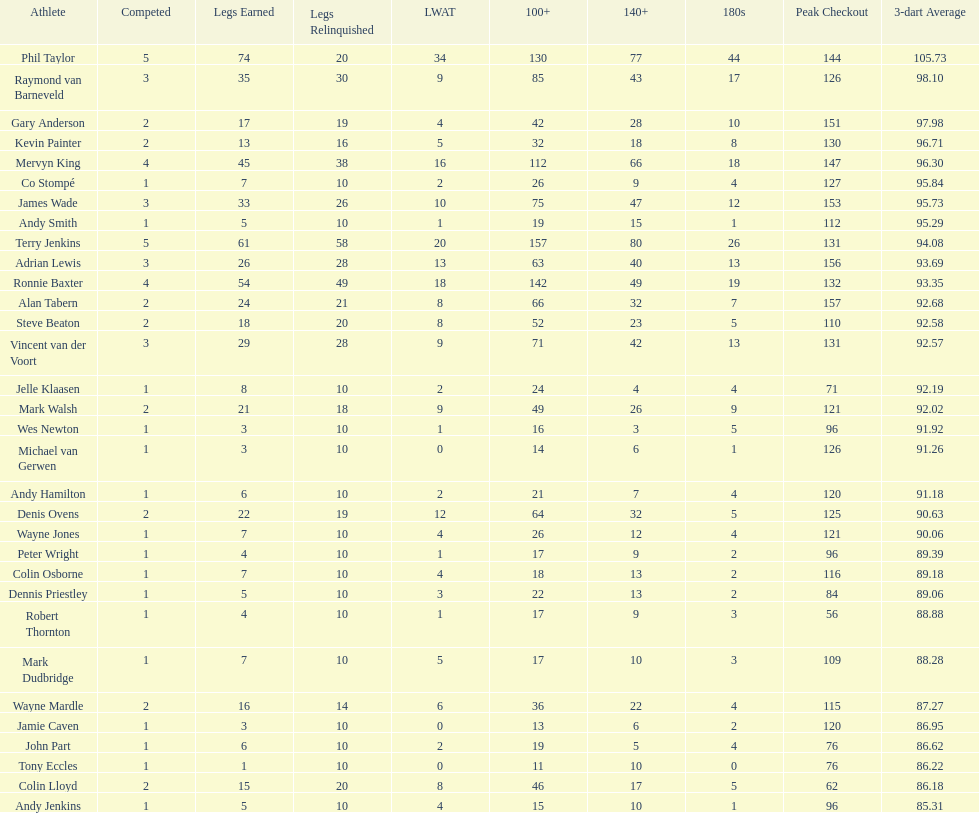What are the number of legs lost by james wade? 26. 